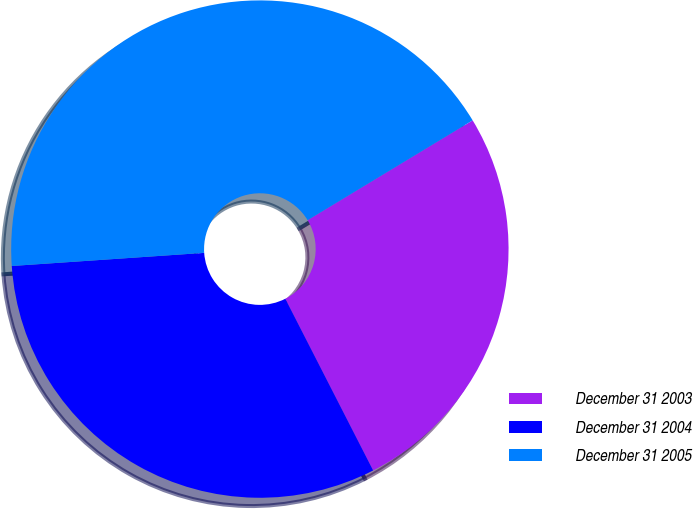Convert chart to OTSL. <chart><loc_0><loc_0><loc_500><loc_500><pie_chart><fcel>December 31 2003<fcel>December 31 2004<fcel>December 31 2005<nl><fcel>26.13%<fcel>31.44%<fcel>42.42%<nl></chart> 